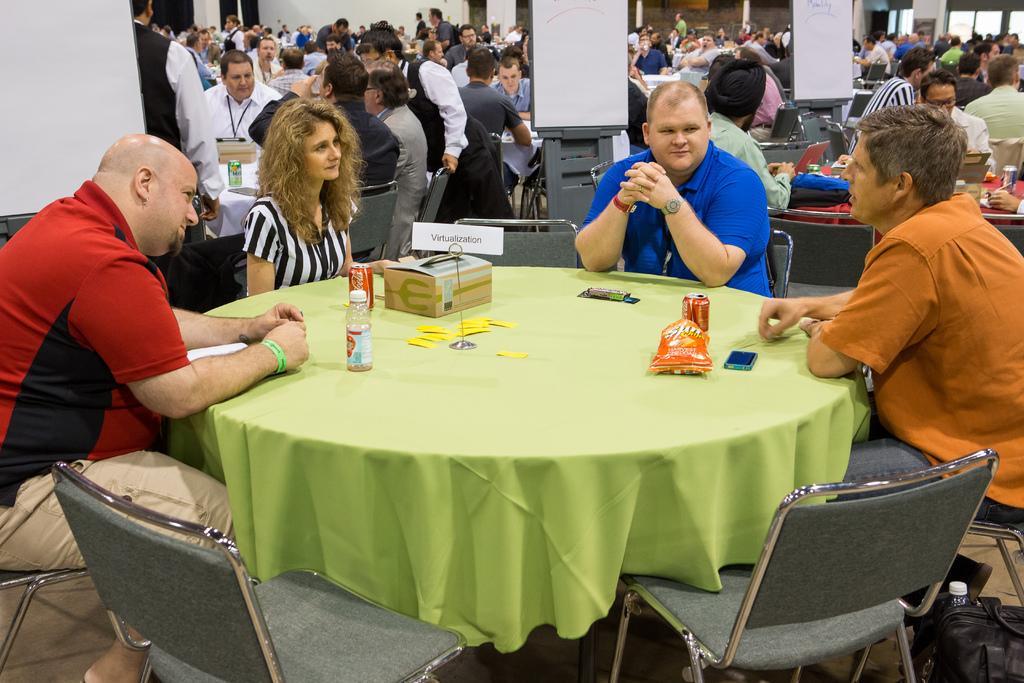Could you give a brief overview of what you see in this image? A group of people are sitting on the chairs around a table. There is a bottle on the table. 